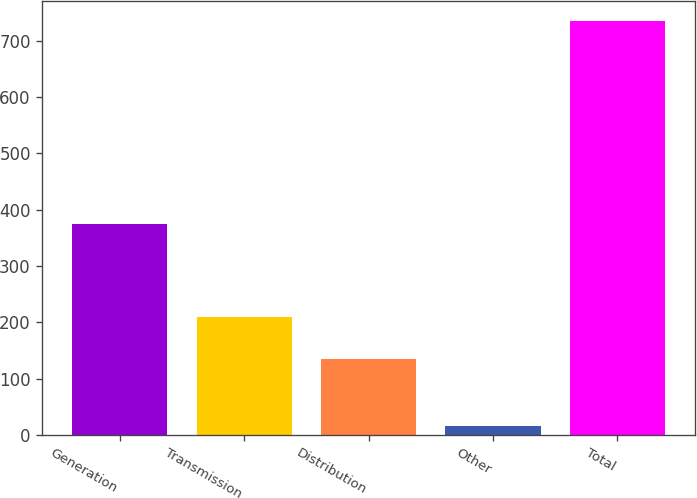Convert chart. <chart><loc_0><loc_0><loc_500><loc_500><bar_chart><fcel>Generation<fcel>Transmission<fcel>Distribution<fcel>Other<fcel>Total<nl><fcel>375<fcel>210<fcel>135<fcel>15<fcel>735<nl></chart> 